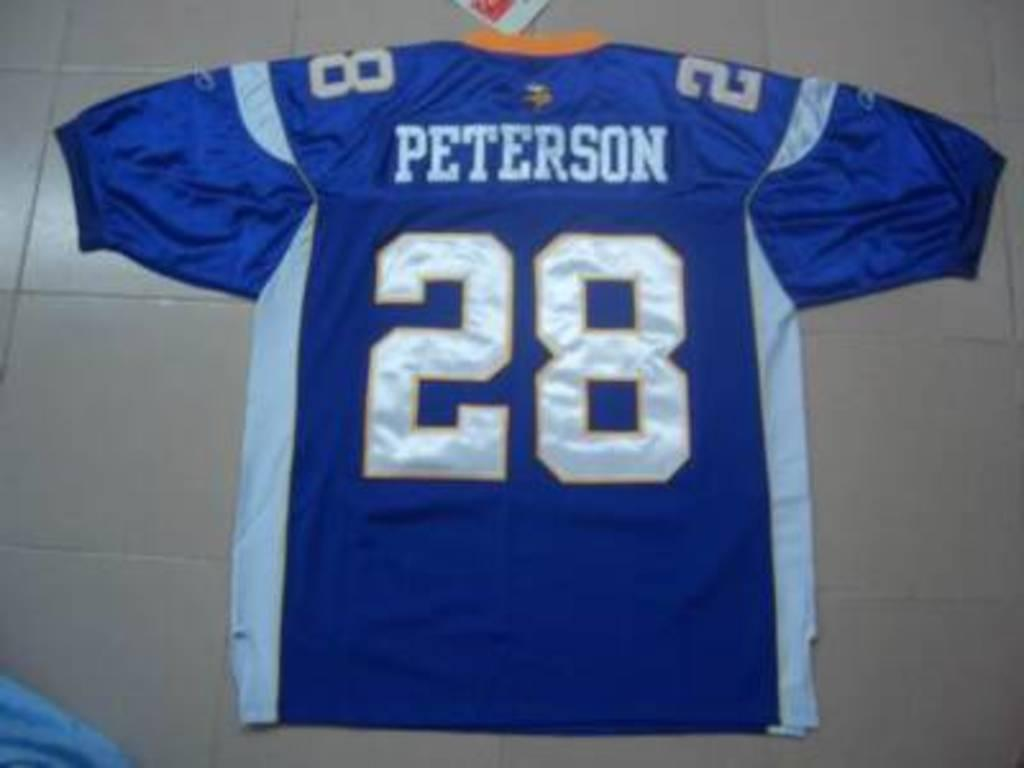<image>
Describe the image concisely. the number 28 is on the back of a jersey 